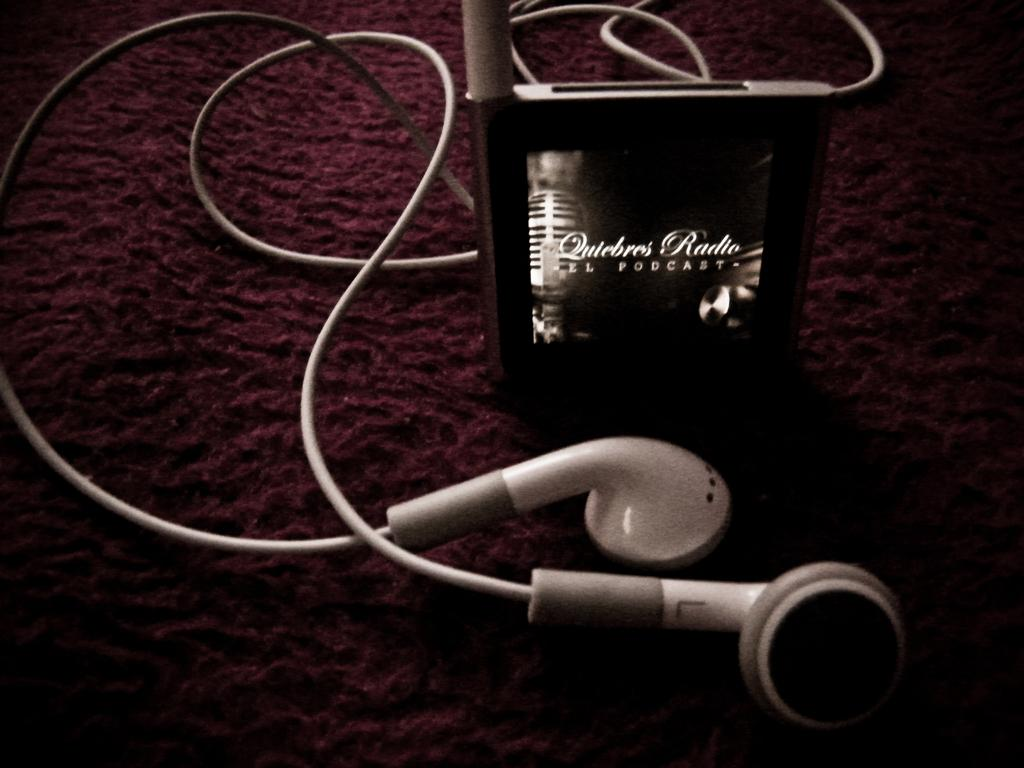What is the main object in the image? There is a device in the image. What is connected to the device? Headphones are connected to the device. What can be seen below the device and headphones? The ground is visible in the image. Can you see a dog playing with a horn in the image? No, there is no dog or horn present in the image. 